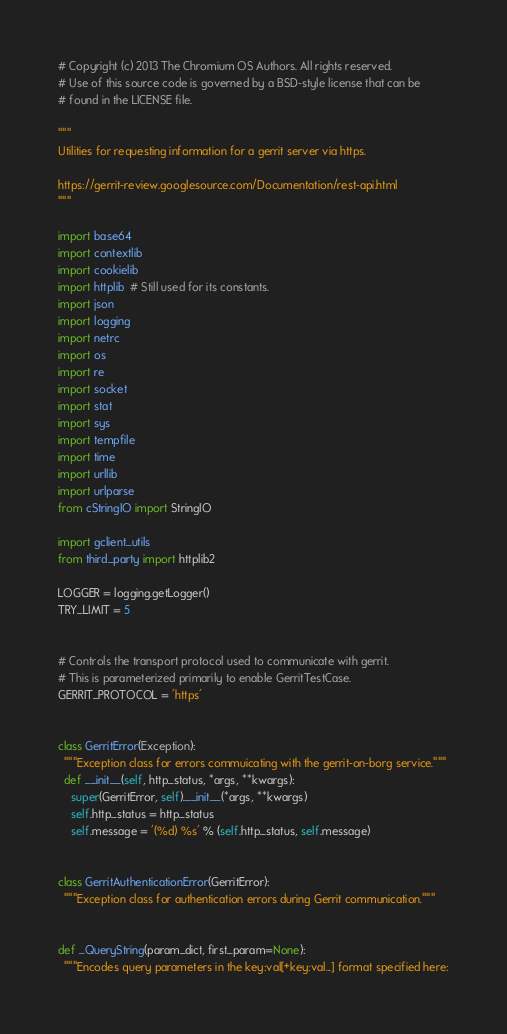<code> <loc_0><loc_0><loc_500><loc_500><_Python_># Copyright (c) 2013 The Chromium OS Authors. All rights reserved.
# Use of this source code is governed by a BSD-style license that can be
# found in the LICENSE file.

"""
Utilities for requesting information for a gerrit server via https.

https://gerrit-review.googlesource.com/Documentation/rest-api.html
"""

import base64
import contextlib
import cookielib
import httplib  # Still used for its constants.
import json
import logging
import netrc
import os
import re
import socket
import stat
import sys
import tempfile
import time
import urllib
import urlparse
from cStringIO import StringIO

import gclient_utils
from third_party import httplib2

LOGGER = logging.getLogger()
TRY_LIMIT = 5


# Controls the transport protocol used to communicate with gerrit.
# This is parameterized primarily to enable GerritTestCase.
GERRIT_PROTOCOL = 'https'


class GerritError(Exception):
  """Exception class for errors commuicating with the gerrit-on-borg service."""
  def __init__(self, http_status, *args, **kwargs):
    super(GerritError, self).__init__(*args, **kwargs)
    self.http_status = http_status
    self.message = '(%d) %s' % (self.http_status, self.message)


class GerritAuthenticationError(GerritError):
  """Exception class for authentication errors during Gerrit communication."""


def _QueryString(param_dict, first_param=None):
  """Encodes query parameters in the key:val[+key:val...] format specified here:
</code> 